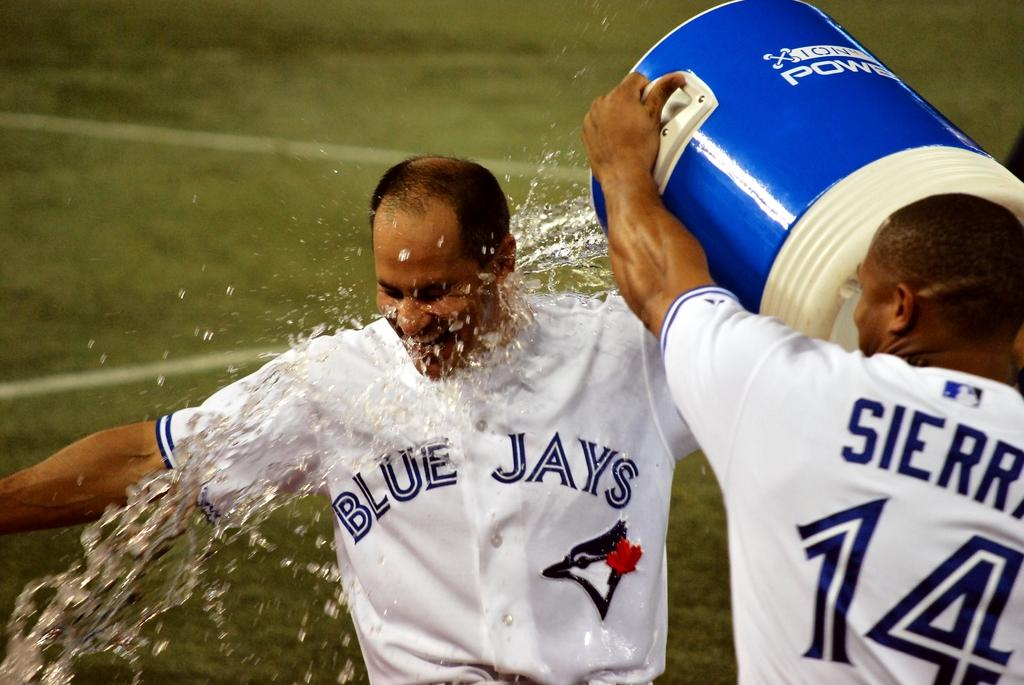<image>
Summarize the visual content of the image. A Blue Jays baseball player celebrates by dumping water on another player. 